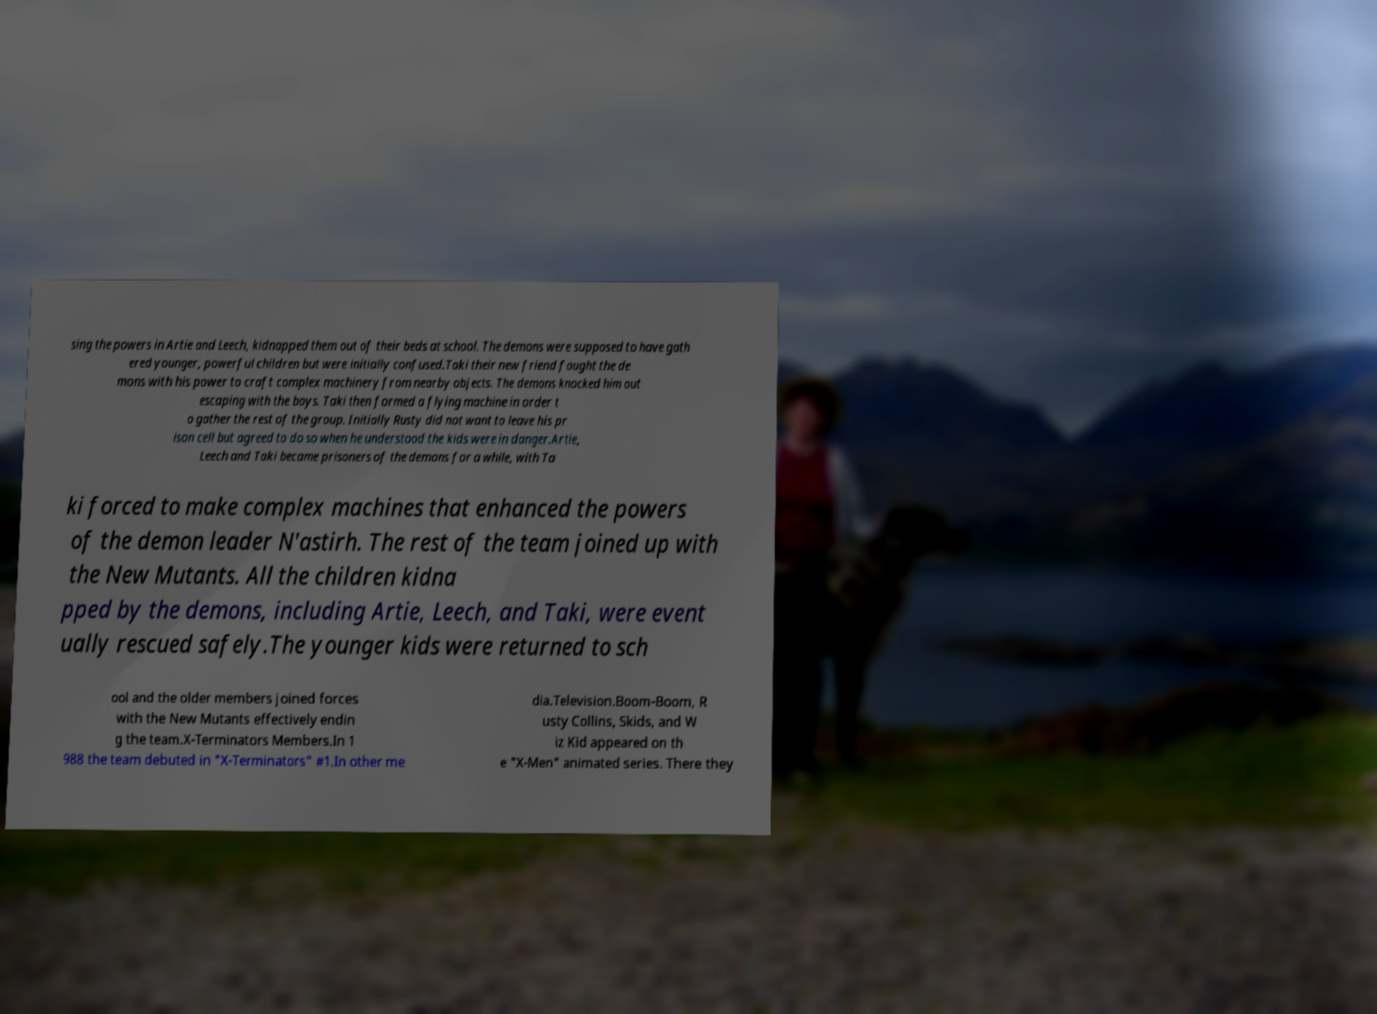For documentation purposes, I need the text within this image transcribed. Could you provide that? sing the powers in Artie and Leech, kidnapped them out of their beds at school. The demons were supposed to have gath ered younger, powerful children but were initially confused.Taki their new friend fought the de mons with his power to craft complex machinery from nearby objects. The demons knocked him out escaping with the boys. Taki then formed a flying machine in order t o gather the rest of the group. Initially Rusty did not want to leave his pr ison cell but agreed to do so when he understood the kids were in danger.Artie, Leech and Taki became prisoners of the demons for a while, with Ta ki forced to make complex machines that enhanced the powers of the demon leader N'astirh. The rest of the team joined up with the New Mutants. All the children kidna pped by the demons, including Artie, Leech, and Taki, were event ually rescued safely.The younger kids were returned to sch ool and the older members joined forces with the New Mutants effectively endin g the team.X-Terminators Members.In 1 988 the team debuted in "X-Terminators" #1.In other me dia.Television.Boom-Boom, R usty Collins, Skids, and W iz Kid appeared on th e "X-Men" animated series. There they 